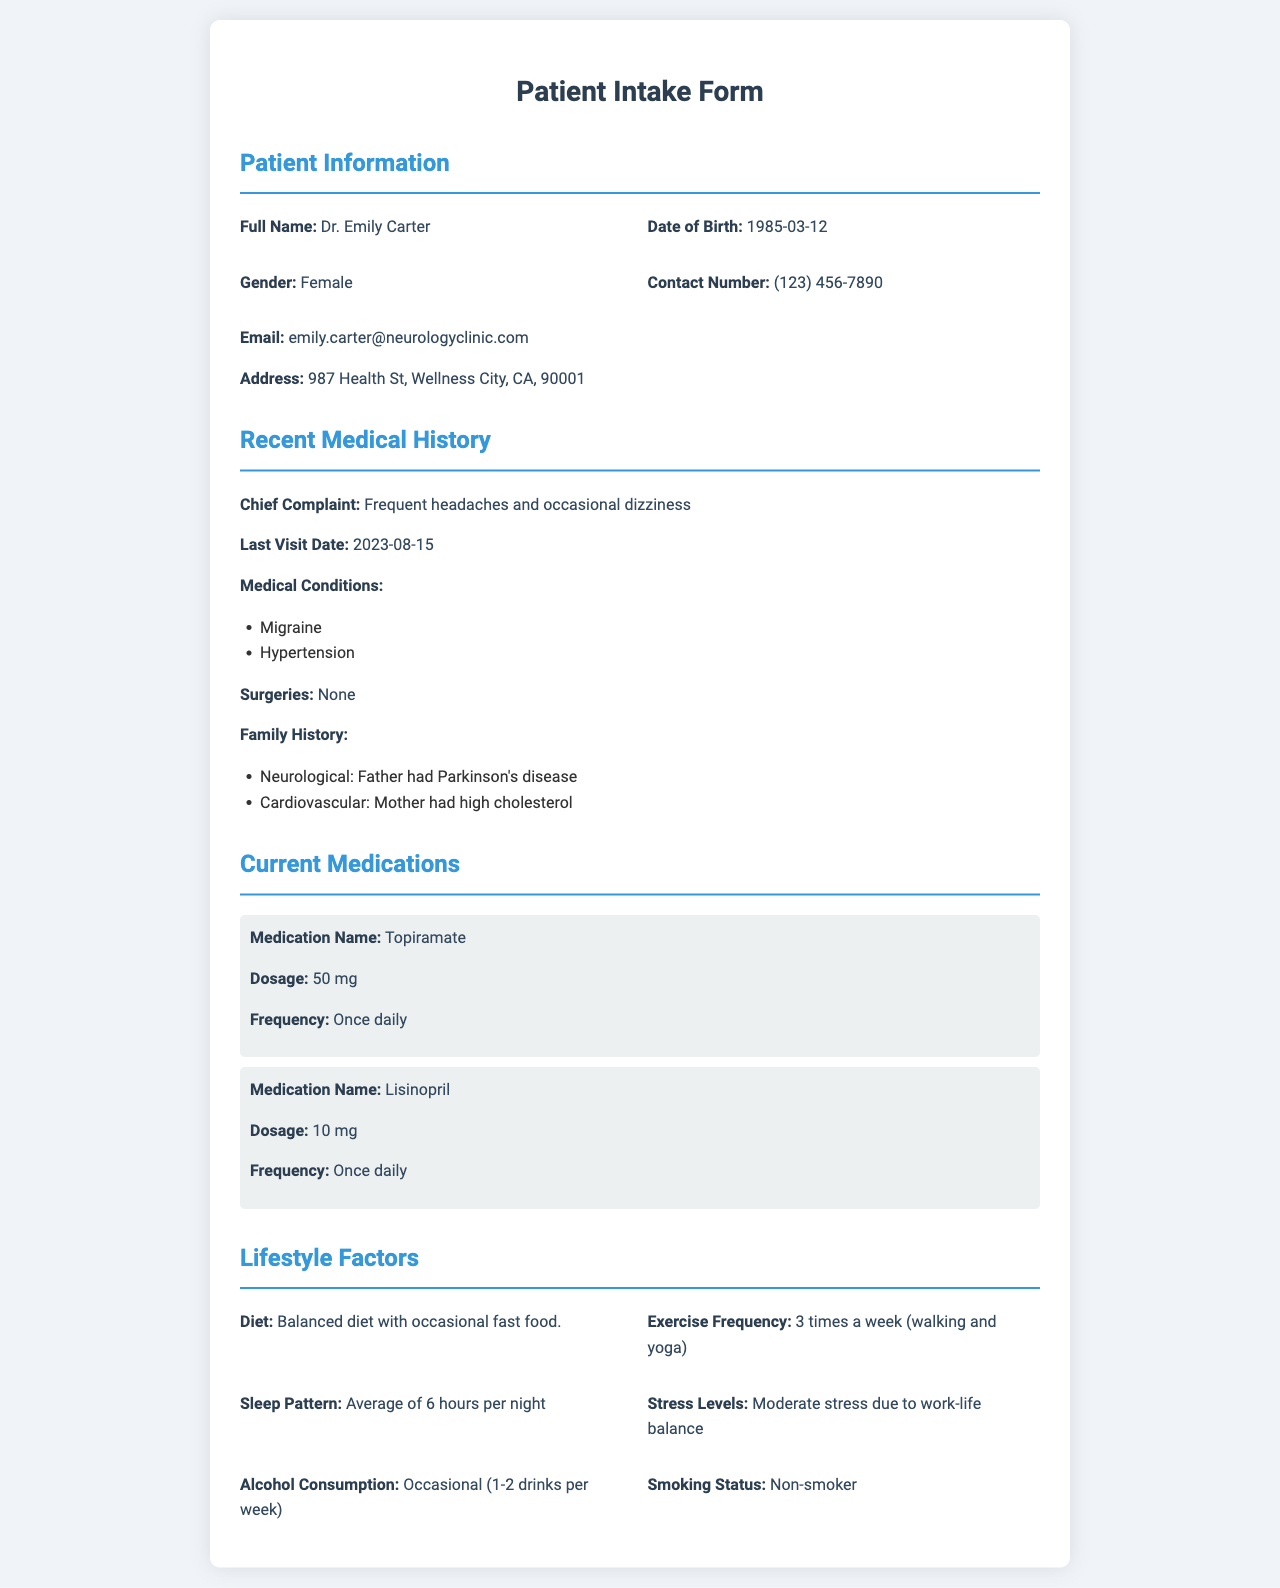What is the chief complaint? The chief complaint is the primary issue reported by the patient, which is stated in the medical history section.
Answer: Frequent headaches and occasional dizziness What medication is taken for migraines? The medication specifically for migraines is mentioned in the current medications section of the document.
Answer: Topiramate How often does the patient exercise? The exercise frequency is detailed in the lifestyle factors section, indicating how often the patient engages in physical activity.
Answer: 3 times a week What is the patient's sleep pattern? The sleep pattern indicates the average amount of sleep the patient gets, found in the lifestyle factors section.
Answer: Average of 6 hours per night Who had Parkinson's disease in the family history? This question seeks to identify the family member with a specific neurological condition mentioned in the family history section.
Answer: Father What is the dosage of Lisinopril? The dosage of Lisinopril is specified under current medications and provides insight into the patient's treatment regimen.
Answer: 10 mg What is the patient's stress level? This question asks about the patient's report on their stress levels as detailed in the lifestyle factors section.
Answer: Moderate stress due to work-life balance What does the patient's diet include? The document outlines dietary habits, which gives an overview of the patient's nutrition.
Answer: Balanced diet with occasional fast food When was the last visit? The last visit date is specified in the recent medical history, indicating the previous consultation's point in time.
Answer: 2023-08-15 